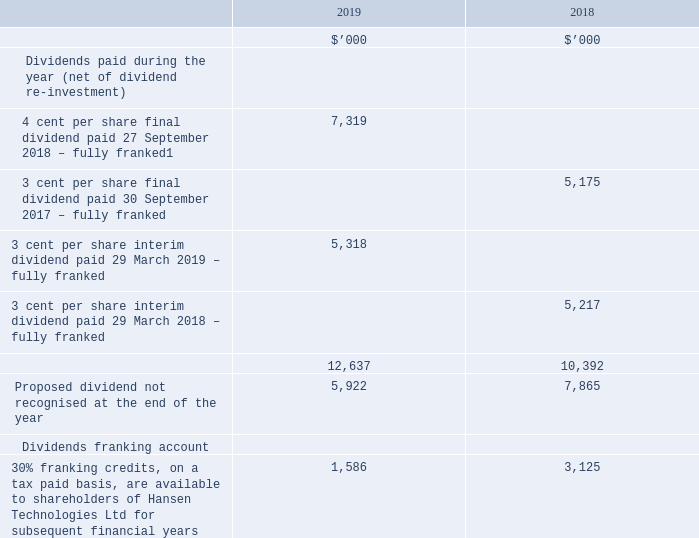20. DIVIDENDS
A regular dividend of 3 cents per share has been declared. This final dividend of 3 cents per share, partially franked to 2.6 cents per share, was announced to the market on 23 August 2019. The amount declared has not been recognised as a liability in the accounts of Hansen Technologies Ltd as at 30 June 2019.
1. The final dividend paid of 4 cents per share, franked to 4 cents, comprised of an ordinary dividend of 3 cents per share, together with a special dividend of 1 cent per share.
The above available amounts are based on the balance of the dividend franking account at year end adjusted for: • franking credits that will arise from the payment of any current tax liability; • franking debits that will arise from the payment of any dividends recognised as a liability at year end; • franking credits that will arise from the receipt of any dividends recognised as receivables at year end; and • franking credits that the entity may be prevented from distributing in subsequent years.
What was the 2019 percentage change of dividends paid between 2018 and 2019 financial years?
Answer scale should be: percent. (12,637 - 10,392) / 10,392 
Answer: 21.6. How many proposed dividends were not recognised at the end of both years?
Answer scale should be: thousand. 5,922 + 7,865 
Answer: 13787. How much was the regular dividend per share? 3 cents per share. How much was the partially franked dividendper share? This final dividend of 3 cents per share, partially franked to 2.6 cents per share. What was the final dividend of 4 cents per share comprised of? 1. the final dividend paid of 4 cents per share, franked to 4 cents, comprised of an ordinary dividend of 3 cents per share, together with a special dividend of 1 cent per share. What was the percentage change in franking credits between 2018 and 2019?
Answer scale should be: percent. (1,586 - 3,125) / 3,125 
Answer: -49.25. 